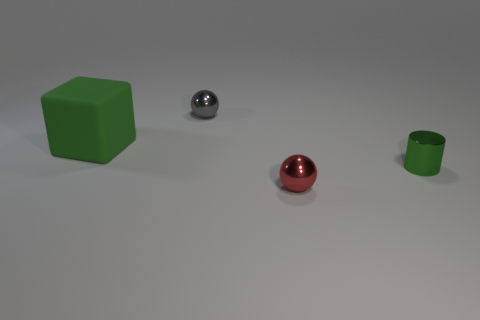There is a tiny thing that is behind the big thing; does it have the same shape as the big rubber object?
Offer a very short reply. No. What is the color of the tiny metal sphere right of the tiny metal ball that is left of the tiny sphere that is in front of the tiny green metallic cylinder?
Offer a terse response. Red. Are there any matte blocks?
Provide a short and direct response. Yes. How many other things are there of the same size as the gray object?
Keep it short and to the point. 2. There is a matte thing; does it have the same color as the tiny object on the right side of the red object?
Provide a succinct answer. Yes. What number of objects are large matte things or tiny green shiny blocks?
Ensure brevity in your answer.  1. Is there any other thing of the same color as the block?
Your answer should be compact. Yes. Does the red thing have the same material as the small gray thing that is behind the green rubber block?
Make the answer very short. Yes. There is a green thing on the right side of the object behind the green block; what shape is it?
Provide a short and direct response. Cylinder. There is a object that is behind the red sphere and in front of the big thing; what shape is it?
Offer a very short reply. Cylinder. 